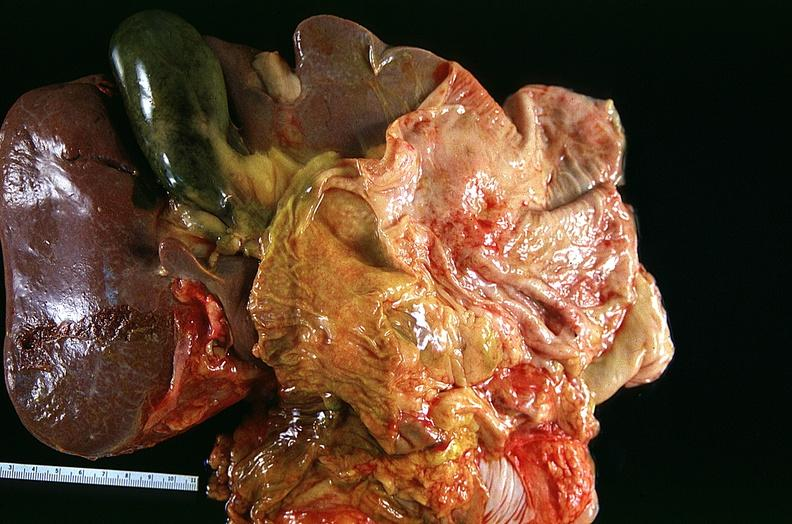what does this image show?
Answer the question using a single word or phrase. Lung 